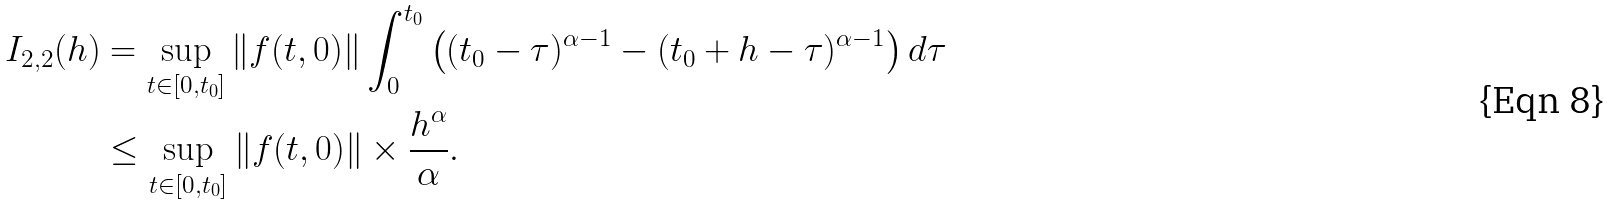Convert formula to latex. <formula><loc_0><loc_0><loc_500><loc_500>I _ { 2 , 2 } ( h ) & = \sup _ { t \in [ 0 , t _ { 0 } ] } \| f ( t , 0 ) \| \int _ { 0 } ^ { t _ { 0 } } \left ( ( t _ { 0 } - \tau ) ^ { \alpha - 1 } - ( t _ { 0 } + h - \tau ) ^ { \alpha - 1 } \right ) d \tau \\ & \leq \sup _ { t \in [ 0 , t _ { 0 } ] } \| f ( t , 0 ) \| \times \frac { h ^ { \alpha } } { \alpha } .</formula> 